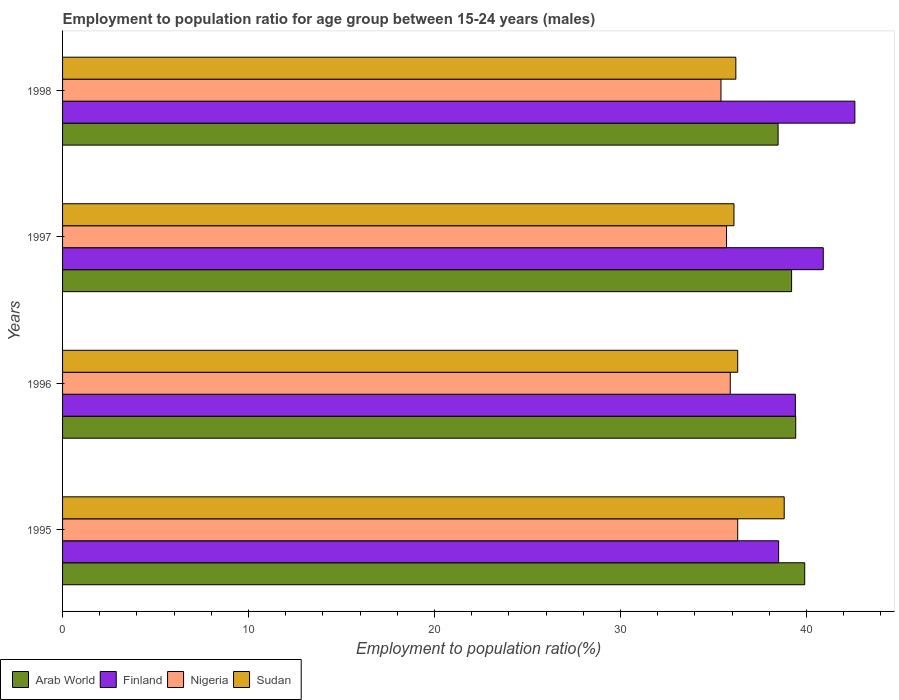How many different coloured bars are there?
Make the answer very short. 4. How many groups of bars are there?
Offer a very short reply. 4. Are the number of bars on each tick of the Y-axis equal?
Offer a terse response. Yes. How many bars are there on the 3rd tick from the top?
Offer a very short reply. 4. What is the employment to population ratio in Nigeria in 1997?
Keep it short and to the point. 35.7. Across all years, what is the maximum employment to population ratio in Sudan?
Ensure brevity in your answer.  38.8. Across all years, what is the minimum employment to population ratio in Arab World?
Provide a short and direct response. 38.47. In which year was the employment to population ratio in Sudan maximum?
Provide a short and direct response. 1995. In which year was the employment to population ratio in Sudan minimum?
Make the answer very short. 1997. What is the total employment to population ratio in Arab World in the graph?
Offer a very short reply. 156.99. What is the difference between the employment to population ratio in Sudan in 1996 and that in 1997?
Your answer should be compact. 0.2. What is the difference between the employment to population ratio in Finland in 1998 and the employment to population ratio in Nigeria in 1995?
Provide a short and direct response. 6.3. What is the average employment to population ratio in Finland per year?
Your response must be concise. 40.35. In the year 1996, what is the difference between the employment to population ratio in Arab World and employment to population ratio in Sudan?
Give a very brief answer. 3.12. In how many years, is the employment to population ratio in Arab World greater than 32 %?
Your answer should be compact. 4. What is the ratio of the employment to population ratio in Finland in 1995 to that in 1998?
Your response must be concise. 0.9. Is the employment to population ratio in Finland in 1996 less than that in 1997?
Keep it short and to the point. Yes. What is the difference between the highest and the second highest employment to population ratio in Nigeria?
Your response must be concise. 0.4. What is the difference between the highest and the lowest employment to population ratio in Finland?
Your answer should be very brief. 4.1. Is the sum of the employment to population ratio in Nigeria in 1996 and 1998 greater than the maximum employment to population ratio in Arab World across all years?
Give a very brief answer. Yes. Is it the case that in every year, the sum of the employment to population ratio in Arab World and employment to population ratio in Sudan is greater than the sum of employment to population ratio in Nigeria and employment to population ratio in Finland?
Give a very brief answer. No. What does the 2nd bar from the top in 1998 represents?
Offer a very short reply. Nigeria. What does the 1st bar from the bottom in 1998 represents?
Ensure brevity in your answer.  Arab World. Are all the bars in the graph horizontal?
Provide a short and direct response. Yes. How many years are there in the graph?
Provide a succinct answer. 4. What is the difference between two consecutive major ticks on the X-axis?
Make the answer very short. 10. Are the values on the major ticks of X-axis written in scientific E-notation?
Keep it short and to the point. No. Where does the legend appear in the graph?
Offer a terse response. Bottom left. How are the legend labels stacked?
Give a very brief answer. Horizontal. What is the title of the graph?
Offer a terse response. Employment to population ratio for age group between 15-24 years (males). What is the label or title of the Y-axis?
Provide a short and direct response. Years. What is the Employment to population ratio(%) in Arab World in 1995?
Provide a short and direct response. 39.9. What is the Employment to population ratio(%) of Finland in 1995?
Provide a short and direct response. 38.5. What is the Employment to population ratio(%) in Nigeria in 1995?
Provide a succinct answer. 36.3. What is the Employment to population ratio(%) in Sudan in 1995?
Provide a short and direct response. 38.8. What is the Employment to population ratio(%) in Arab World in 1996?
Give a very brief answer. 39.42. What is the Employment to population ratio(%) of Finland in 1996?
Your response must be concise. 39.4. What is the Employment to population ratio(%) in Nigeria in 1996?
Your answer should be very brief. 35.9. What is the Employment to population ratio(%) of Sudan in 1996?
Your answer should be very brief. 36.3. What is the Employment to population ratio(%) of Arab World in 1997?
Ensure brevity in your answer.  39.2. What is the Employment to population ratio(%) of Finland in 1997?
Provide a short and direct response. 40.9. What is the Employment to population ratio(%) in Nigeria in 1997?
Your answer should be very brief. 35.7. What is the Employment to population ratio(%) in Sudan in 1997?
Your answer should be compact. 36.1. What is the Employment to population ratio(%) in Arab World in 1998?
Give a very brief answer. 38.47. What is the Employment to population ratio(%) of Finland in 1998?
Your answer should be very brief. 42.6. What is the Employment to population ratio(%) of Nigeria in 1998?
Make the answer very short. 35.4. What is the Employment to population ratio(%) of Sudan in 1998?
Your answer should be very brief. 36.2. Across all years, what is the maximum Employment to population ratio(%) of Arab World?
Your answer should be compact. 39.9. Across all years, what is the maximum Employment to population ratio(%) in Finland?
Your answer should be compact. 42.6. Across all years, what is the maximum Employment to population ratio(%) of Nigeria?
Your answer should be compact. 36.3. Across all years, what is the maximum Employment to population ratio(%) in Sudan?
Give a very brief answer. 38.8. Across all years, what is the minimum Employment to population ratio(%) in Arab World?
Provide a short and direct response. 38.47. Across all years, what is the minimum Employment to population ratio(%) of Finland?
Offer a very short reply. 38.5. Across all years, what is the minimum Employment to population ratio(%) in Nigeria?
Keep it short and to the point. 35.4. Across all years, what is the minimum Employment to population ratio(%) in Sudan?
Give a very brief answer. 36.1. What is the total Employment to population ratio(%) of Arab World in the graph?
Provide a short and direct response. 156.99. What is the total Employment to population ratio(%) of Finland in the graph?
Ensure brevity in your answer.  161.4. What is the total Employment to population ratio(%) in Nigeria in the graph?
Provide a short and direct response. 143.3. What is the total Employment to population ratio(%) in Sudan in the graph?
Keep it short and to the point. 147.4. What is the difference between the Employment to population ratio(%) of Arab World in 1995 and that in 1996?
Offer a terse response. 0.48. What is the difference between the Employment to population ratio(%) in Finland in 1995 and that in 1996?
Keep it short and to the point. -0.9. What is the difference between the Employment to population ratio(%) in Arab World in 1995 and that in 1997?
Provide a short and direct response. 0.7. What is the difference between the Employment to population ratio(%) in Finland in 1995 and that in 1997?
Your answer should be compact. -2.4. What is the difference between the Employment to population ratio(%) in Arab World in 1995 and that in 1998?
Make the answer very short. 1.43. What is the difference between the Employment to population ratio(%) of Finland in 1995 and that in 1998?
Provide a succinct answer. -4.1. What is the difference between the Employment to population ratio(%) in Nigeria in 1995 and that in 1998?
Offer a very short reply. 0.9. What is the difference between the Employment to population ratio(%) of Sudan in 1995 and that in 1998?
Your answer should be compact. 2.6. What is the difference between the Employment to population ratio(%) of Arab World in 1996 and that in 1997?
Keep it short and to the point. 0.22. What is the difference between the Employment to population ratio(%) of Sudan in 1996 and that in 1997?
Offer a very short reply. 0.2. What is the difference between the Employment to population ratio(%) of Arab World in 1996 and that in 1998?
Your response must be concise. 0.95. What is the difference between the Employment to population ratio(%) in Sudan in 1996 and that in 1998?
Ensure brevity in your answer.  0.1. What is the difference between the Employment to population ratio(%) of Arab World in 1997 and that in 1998?
Your response must be concise. 0.73. What is the difference between the Employment to population ratio(%) in Arab World in 1995 and the Employment to population ratio(%) in Finland in 1996?
Your response must be concise. 0.5. What is the difference between the Employment to population ratio(%) in Arab World in 1995 and the Employment to population ratio(%) in Nigeria in 1996?
Give a very brief answer. 4. What is the difference between the Employment to population ratio(%) in Arab World in 1995 and the Employment to population ratio(%) in Sudan in 1996?
Offer a terse response. 3.6. What is the difference between the Employment to population ratio(%) of Nigeria in 1995 and the Employment to population ratio(%) of Sudan in 1996?
Your answer should be very brief. 0. What is the difference between the Employment to population ratio(%) in Arab World in 1995 and the Employment to population ratio(%) in Finland in 1997?
Make the answer very short. -1. What is the difference between the Employment to population ratio(%) in Arab World in 1995 and the Employment to population ratio(%) in Nigeria in 1997?
Your answer should be compact. 4.2. What is the difference between the Employment to population ratio(%) in Arab World in 1995 and the Employment to population ratio(%) in Sudan in 1997?
Give a very brief answer. 3.8. What is the difference between the Employment to population ratio(%) in Finland in 1995 and the Employment to population ratio(%) in Sudan in 1997?
Make the answer very short. 2.4. What is the difference between the Employment to population ratio(%) in Nigeria in 1995 and the Employment to population ratio(%) in Sudan in 1997?
Make the answer very short. 0.2. What is the difference between the Employment to population ratio(%) in Arab World in 1995 and the Employment to population ratio(%) in Finland in 1998?
Ensure brevity in your answer.  -2.7. What is the difference between the Employment to population ratio(%) of Arab World in 1995 and the Employment to population ratio(%) of Nigeria in 1998?
Offer a terse response. 4.5. What is the difference between the Employment to population ratio(%) in Arab World in 1995 and the Employment to population ratio(%) in Sudan in 1998?
Ensure brevity in your answer.  3.7. What is the difference between the Employment to population ratio(%) in Finland in 1995 and the Employment to population ratio(%) in Sudan in 1998?
Your answer should be compact. 2.3. What is the difference between the Employment to population ratio(%) in Nigeria in 1995 and the Employment to population ratio(%) in Sudan in 1998?
Keep it short and to the point. 0.1. What is the difference between the Employment to population ratio(%) in Arab World in 1996 and the Employment to population ratio(%) in Finland in 1997?
Offer a very short reply. -1.48. What is the difference between the Employment to population ratio(%) in Arab World in 1996 and the Employment to population ratio(%) in Nigeria in 1997?
Your answer should be very brief. 3.72. What is the difference between the Employment to population ratio(%) in Arab World in 1996 and the Employment to population ratio(%) in Sudan in 1997?
Provide a succinct answer. 3.32. What is the difference between the Employment to population ratio(%) of Finland in 1996 and the Employment to population ratio(%) of Sudan in 1997?
Offer a very short reply. 3.3. What is the difference between the Employment to population ratio(%) of Arab World in 1996 and the Employment to population ratio(%) of Finland in 1998?
Your response must be concise. -3.18. What is the difference between the Employment to population ratio(%) of Arab World in 1996 and the Employment to population ratio(%) of Nigeria in 1998?
Provide a short and direct response. 4.02. What is the difference between the Employment to population ratio(%) of Arab World in 1996 and the Employment to population ratio(%) of Sudan in 1998?
Your response must be concise. 3.22. What is the difference between the Employment to population ratio(%) in Finland in 1996 and the Employment to population ratio(%) in Nigeria in 1998?
Provide a short and direct response. 4. What is the difference between the Employment to population ratio(%) of Finland in 1996 and the Employment to population ratio(%) of Sudan in 1998?
Provide a short and direct response. 3.2. What is the difference between the Employment to population ratio(%) of Nigeria in 1996 and the Employment to population ratio(%) of Sudan in 1998?
Offer a terse response. -0.3. What is the difference between the Employment to population ratio(%) of Arab World in 1997 and the Employment to population ratio(%) of Finland in 1998?
Your answer should be compact. -3.4. What is the difference between the Employment to population ratio(%) of Arab World in 1997 and the Employment to population ratio(%) of Nigeria in 1998?
Your response must be concise. 3.8. What is the difference between the Employment to population ratio(%) of Arab World in 1997 and the Employment to population ratio(%) of Sudan in 1998?
Offer a very short reply. 3. What is the difference between the Employment to population ratio(%) of Finland in 1997 and the Employment to population ratio(%) of Nigeria in 1998?
Make the answer very short. 5.5. What is the average Employment to population ratio(%) in Arab World per year?
Keep it short and to the point. 39.25. What is the average Employment to population ratio(%) in Finland per year?
Provide a succinct answer. 40.35. What is the average Employment to population ratio(%) in Nigeria per year?
Offer a terse response. 35.83. What is the average Employment to population ratio(%) of Sudan per year?
Your answer should be compact. 36.85. In the year 1995, what is the difference between the Employment to population ratio(%) in Arab World and Employment to population ratio(%) in Finland?
Your answer should be very brief. 1.4. In the year 1995, what is the difference between the Employment to population ratio(%) in Arab World and Employment to population ratio(%) in Nigeria?
Ensure brevity in your answer.  3.6. In the year 1995, what is the difference between the Employment to population ratio(%) in Arab World and Employment to population ratio(%) in Sudan?
Offer a terse response. 1.1. In the year 1995, what is the difference between the Employment to population ratio(%) in Finland and Employment to population ratio(%) in Nigeria?
Your response must be concise. 2.2. In the year 1995, what is the difference between the Employment to population ratio(%) of Finland and Employment to population ratio(%) of Sudan?
Ensure brevity in your answer.  -0.3. In the year 1996, what is the difference between the Employment to population ratio(%) of Arab World and Employment to population ratio(%) of Finland?
Ensure brevity in your answer.  0.02. In the year 1996, what is the difference between the Employment to population ratio(%) of Arab World and Employment to population ratio(%) of Nigeria?
Offer a terse response. 3.52. In the year 1996, what is the difference between the Employment to population ratio(%) of Arab World and Employment to population ratio(%) of Sudan?
Your response must be concise. 3.12. In the year 1996, what is the difference between the Employment to population ratio(%) in Finland and Employment to population ratio(%) in Sudan?
Provide a succinct answer. 3.1. In the year 1996, what is the difference between the Employment to population ratio(%) in Nigeria and Employment to population ratio(%) in Sudan?
Provide a short and direct response. -0.4. In the year 1997, what is the difference between the Employment to population ratio(%) of Arab World and Employment to population ratio(%) of Finland?
Your answer should be compact. -1.7. In the year 1997, what is the difference between the Employment to population ratio(%) of Arab World and Employment to population ratio(%) of Nigeria?
Offer a very short reply. 3.5. In the year 1997, what is the difference between the Employment to population ratio(%) in Arab World and Employment to population ratio(%) in Sudan?
Your answer should be very brief. 3.1. In the year 1997, what is the difference between the Employment to population ratio(%) in Finland and Employment to population ratio(%) in Nigeria?
Your response must be concise. 5.2. In the year 1997, what is the difference between the Employment to population ratio(%) of Nigeria and Employment to population ratio(%) of Sudan?
Your response must be concise. -0.4. In the year 1998, what is the difference between the Employment to population ratio(%) of Arab World and Employment to population ratio(%) of Finland?
Provide a short and direct response. -4.13. In the year 1998, what is the difference between the Employment to population ratio(%) in Arab World and Employment to population ratio(%) in Nigeria?
Offer a very short reply. 3.07. In the year 1998, what is the difference between the Employment to population ratio(%) of Arab World and Employment to population ratio(%) of Sudan?
Your response must be concise. 2.27. In the year 1998, what is the difference between the Employment to population ratio(%) in Nigeria and Employment to population ratio(%) in Sudan?
Provide a succinct answer. -0.8. What is the ratio of the Employment to population ratio(%) in Arab World in 1995 to that in 1996?
Ensure brevity in your answer.  1.01. What is the ratio of the Employment to population ratio(%) in Finland in 1995 to that in 1996?
Ensure brevity in your answer.  0.98. What is the ratio of the Employment to population ratio(%) of Nigeria in 1995 to that in 1996?
Make the answer very short. 1.01. What is the ratio of the Employment to population ratio(%) in Sudan in 1995 to that in 1996?
Ensure brevity in your answer.  1.07. What is the ratio of the Employment to population ratio(%) in Arab World in 1995 to that in 1997?
Provide a succinct answer. 1.02. What is the ratio of the Employment to population ratio(%) in Finland in 1995 to that in 1997?
Offer a very short reply. 0.94. What is the ratio of the Employment to population ratio(%) in Nigeria in 1995 to that in 1997?
Make the answer very short. 1.02. What is the ratio of the Employment to population ratio(%) of Sudan in 1995 to that in 1997?
Provide a succinct answer. 1.07. What is the ratio of the Employment to population ratio(%) of Arab World in 1995 to that in 1998?
Provide a short and direct response. 1.04. What is the ratio of the Employment to population ratio(%) of Finland in 1995 to that in 1998?
Your answer should be very brief. 0.9. What is the ratio of the Employment to population ratio(%) in Nigeria in 1995 to that in 1998?
Ensure brevity in your answer.  1.03. What is the ratio of the Employment to population ratio(%) in Sudan in 1995 to that in 1998?
Your response must be concise. 1.07. What is the ratio of the Employment to population ratio(%) in Arab World in 1996 to that in 1997?
Offer a terse response. 1.01. What is the ratio of the Employment to population ratio(%) in Finland in 1996 to that in 1997?
Keep it short and to the point. 0.96. What is the ratio of the Employment to population ratio(%) of Nigeria in 1996 to that in 1997?
Offer a terse response. 1.01. What is the ratio of the Employment to population ratio(%) of Sudan in 1996 to that in 1997?
Provide a short and direct response. 1.01. What is the ratio of the Employment to population ratio(%) in Arab World in 1996 to that in 1998?
Your answer should be very brief. 1.02. What is the ratio of the Employment to population ratio(%) of Finland in 1996 to that in 1998?
Your response must be concise. 0.92. What is the ratio of the Employment to population ratio(%) of Nigeria in 1996 to that in 1998?
Provide a succinct answer. 1.01. What is the ratio of the Employment to population ratio(%) of Sudan in 1996 to that in 1998?
Your response must be concise. 1. What is the ratio of the Employment to population ratio(%) of Arab World in 1997 to that in 1998?
Your answer should be very brief. 1.02. What is the ratio of the Employment to population ratio(%) in Finland in 1997 to that in 1998?
Make the answer very short. 0.96. What is the ratio of the Employment to population ratio(%) in Nigeria in 1997 to that in 1998?
Provide a short and direct response. 1.01. What is the ratio of the Employment to population ratio(%) in Sudan in 1997 to that in 1998?
Keep it short and to the point. 1. What is the difference between the highest and the second highest Employment to population ratio(%) in Arab World?
Keep it short and to the point. 0.48. What is the difference between the highest and the second highest Employment to population ratio(%) in Finland?
Keep it short and to the point. 1.7. What is the difference between the highest and the second highest Employment to population ratio(%) in Nigeria?
Offer a terse response. 0.4. What is the difference between the highest and the lowest Employment to population ratio(%) in Arab World?
Ensure brevity in your answer.  1.43. What is the difference between the highest and the lowest Employment to population ratio(%) of Finland?
Provide a succinct answer. 4.1. What is the difference between the highest and the lowest Employment to population ratio(%) in Nigeria?
Offer a very short reply. 0.9. 